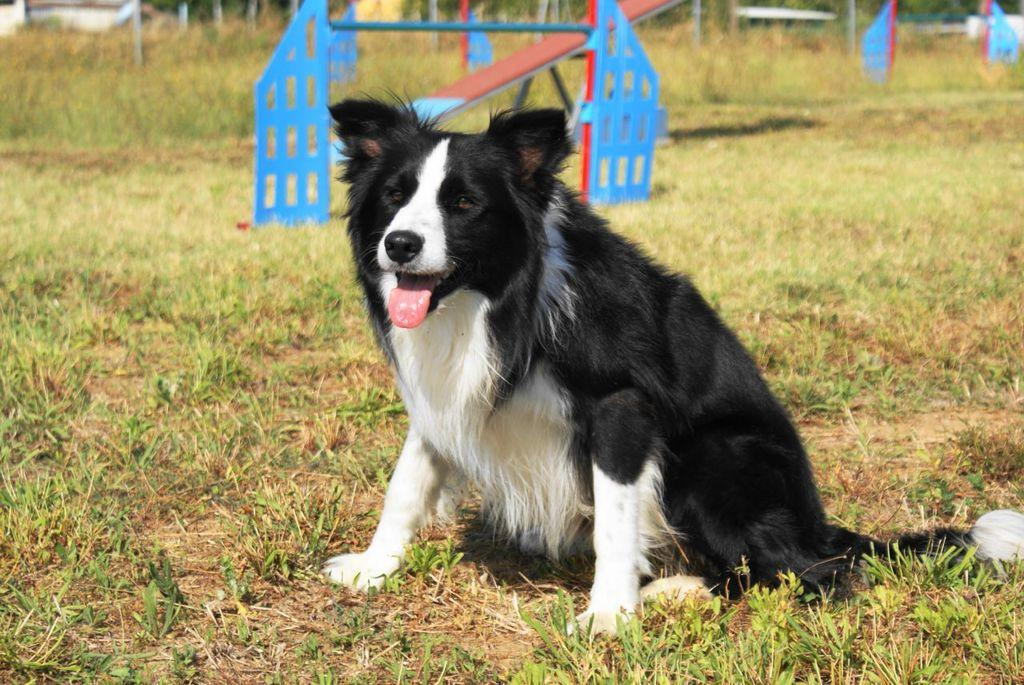What type of animal is in the image? There is a dog in the image. Where is the dog located? The dog is on the ground. What is on the ground where the dog is? There is grass on the ground. What can be seen in the background of the image? There is a seesaw and other objects in the background of the image. What type of badge is the dog wearing in the image? There is no badge present on the dog in the image. What vegetables are being grown in the background of the image? There are no vegetables visible in the background of the image. 